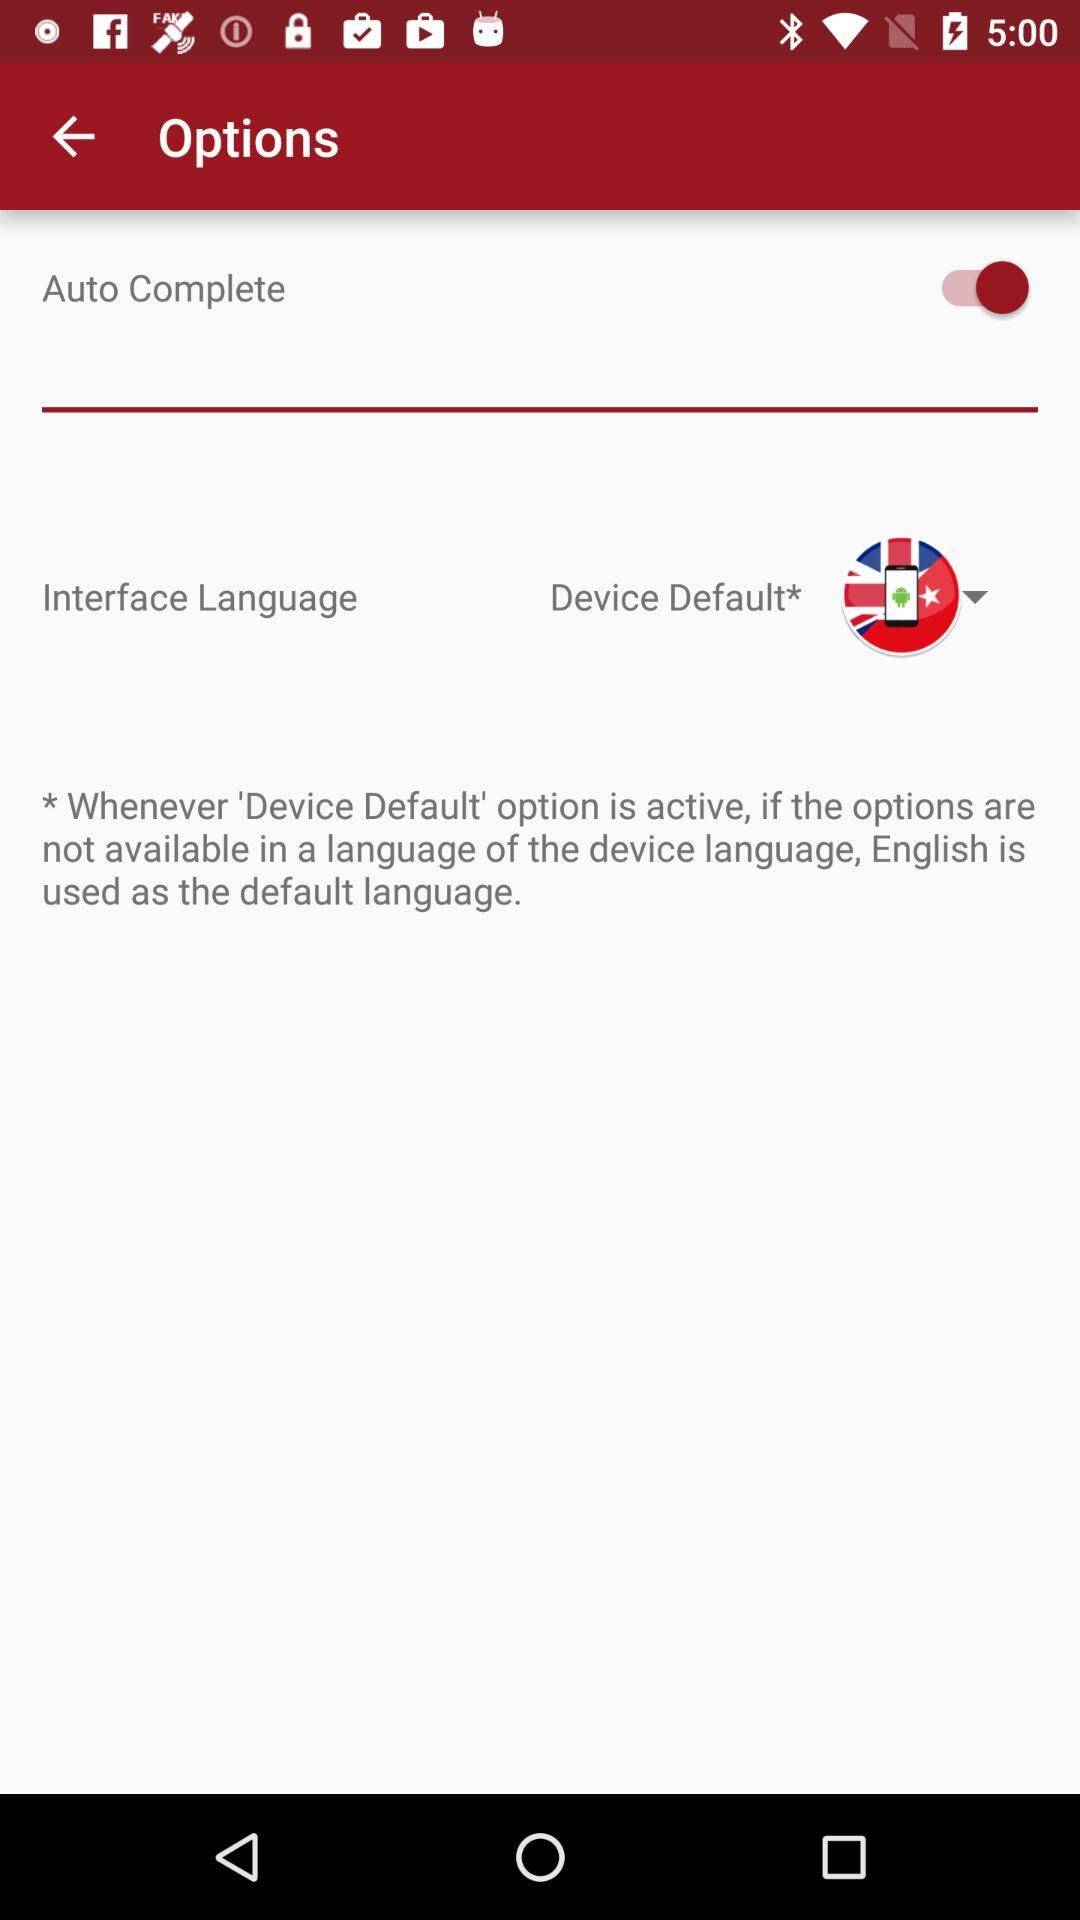Which language is selected? The selected language is English. 